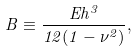Convert formula to latex. <formula><loc_0><loc_0><loc_500><loc_500>B \equiv \frac { E h ^ { 3 } } { 1 2 ( 1 - \nu ^ { 2 } ) } ,</formula> 